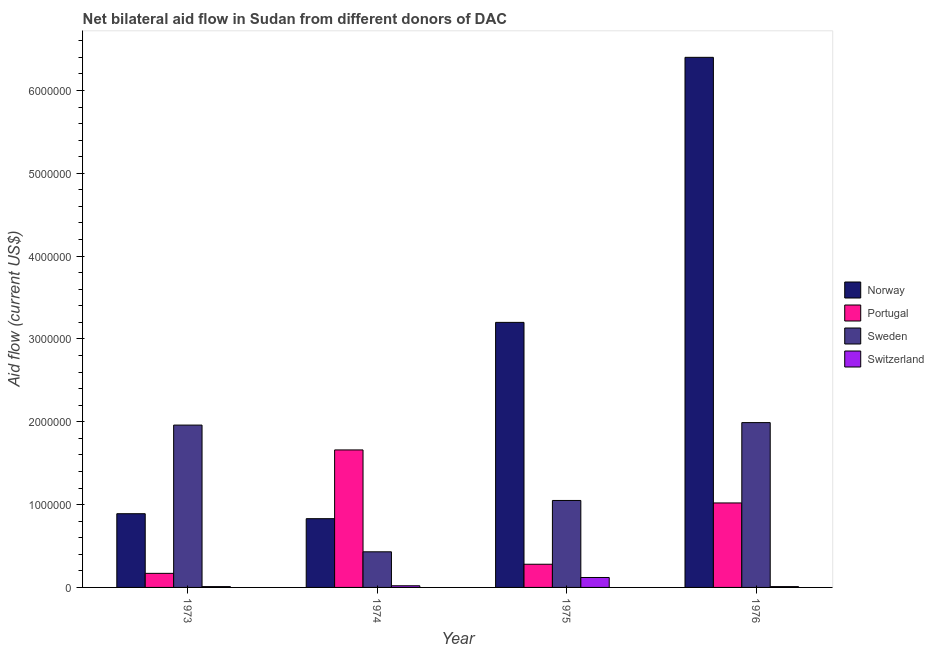How many different coloured bars are there?
Give a very brief answer. 4. How many groups of bars are there?
Offer a very short reply. 4. Are the number of bars per tick equal to the number of legend labels?
Offer a terse response. Yes. Are the number of bars on each tick of the X-axis equal?
Give a very brief answer. Yes. What is the label of the 4th group of bars from the left?
Ensure brevity in your answer.  1976. What is the amount of aid given by switzerland in 1973?
Give a very brief answer. 10000. Across all years, what is the maximum amount of aid given by portugal?
Offer a terse response. 1.66e+06. Across all years, what is the minimum amount of aid given by portugal?
Offer a very short reply. 1.70e+05. In which year was the amount of aid given by sweden maximum?
Provide a short and direct response. 1976. What is the total amount of aid given by switzerland in the graph?
Provide a succinct answer. 1.60e+05. What is the difference between the amount of aid given by switzerland in 1974 and that in 1976?
Offer a terse response. 10000. What is the difference between the amount of aid given by switzerland in 1976 and the amount of aid given by portugal in 1975?
Keep it short and to the point. -1.10e+05. What is the ratio of the amount of aid given by switzerland in 1974 to that in 1975?
Give a very brief answer. 0.17. Is the amount of aid given by norway in 1974 less than that in 1976?
Keep it short and to the point. Yes. What is the difference between the highest and the second highest amount of aid given by norway?
Keep it short and to the point. 3.20e+06. What is the difference between the highest and the lowest amount of aid given by norway?
Provide a succinct answer. 5.57e+06. In how many years, is the amount of aid given by sweden greater than the average amount of aid given by sweden taken over all years?
Offer a very short reply. 2. Is the sum of the amount of aid given by switzerland in 1973 and 1974 greater than the maximum amount of aid given by sweden across all years?
Your response must be concise. No. What does the 1st bar from the left in 1976 represents?
Ensure brevity in your answer.  Norway. What does the 2nd bar from the right in 1976 represents?
Ensure brevity in your answer.  Sweden. Is it the case that in every year, the sum of the amount of aid given by norway and amount of aid given by portugal is greater than the amount of aid given by sweden?
Keep it short and to the point. No. How many years are there in the graph?
Your answer should be compact. 4. Are the values on the major ticks of Y-axis written in scientific E-notation?
Give a very brief answer. No. Does the graph contain grids?
Ensure brevity in your answer.  No. How many legend labels are there?
Your response must be concise. 4. What is the title of the graph?
Your answer should be compact. Net bilateral aid flow in Sudan from different donors of DAC. What is the label or title of the X-axis?
Make the answer very short. Year. What is the label or title of the Y-axis?
Ensure brevity in your answer.  Aid flow (current US$). What is the Aid flow (current US$) of Norway in 1973?
Provide a short and direct response. 8.90e+05. What is the Aid flow (current US$) in Sweden in 1973?
Offer a terse response. 1.96e+06. What is the Aid flow (current US$) in Norway in 1974?
Offer a terse response. 8.30e+05. What is the Aid flow (current US$) in Portugal in 1974?
Make the answer very short. 1.66e+06. What is the Aid flow (current US$) in Sweden in 1974?
Your answer should be very brief. 4.30e+05. What is the Aid flow (current US$) in Norway in 1975?
Your answer should be compact. 3.20e+06. What is the Aid flow (current US$) in Sweden in 1975?
Keep it short and to the point. 1.05e+06. What is the Aid flow (current US$) of Norway in 1976?
Provide a succinct answer. 6.40e+06. What is the Aid flow (current US$) in Portugal in 1976?
Offer a very short reply. 1.02e+06. What is the Aid flow (current US$) in Sweden in 1976?
Your response must be concise. 1.99e+06. Across all years, what is the maximum Aid flow (current US$) in Norway?
Make the answer very short. 6.40e+06. Across all years, what is the maximum Aid flow (current US$) of Portugal?
Keep it short and to the point. 1.66e+06. Across all years, what is the maximum Aid flow (current US$) in Sweden?
Your answer should be very brief. 1.99e+06. Across all years, what is the minimum Aid flow (current US$) in Norway?
Offer a terse response. 8.30e+05. Across all years, what is the minimum Aid flow (current US$) of Portugal?
Give a very brief answer. 1.70e+05. What is the total Aid flow (current US$) in Norway in the graph?
Ensure brevity in your answer.  1.13e+07. What is the total Aid flow (current US$) in Portugal in the graph?
Your answer should be very brief. 3.13e+06. What is the total Aid flow (current US$) of Sweden in the graph?
Make the answer very short. 5.43e+06. What is the difference between the Aid flow (current US$) in Portugal in 1973 and that in 1974?
Offer a terse response. -1.49e+06. What is the difference between the Aid flow (current US$) in Sweden in 1973 and that in 1974?
Make the answer very short. 1.53e+06. What is the difference between the Aid flow (current US$) of Switzerland in 1973 and that in 1974?
Your answer should be very brief. -10000. What is the difference between the Aid flow (current US$) of Norway in 1973 and that in 1975?
Your answer should be compact. -2.31e+06. What is the difference between the Aid flow (current US$) of Portugal in 1973 and that in 1975?
Keep it short and to the point. -1.10e+05. What is the difference between the Aid flow (current US$) of Sweden in 1973 and that in 1975?
Ensure brevity in your answer.  9.10e+05. What is the difference between the Aid flow (current US$) in Norway in 1973 and that in 1976?
Your response must be concise. -5.51e+06. What is the difference between the Aid flow (current US$) in Portugal in 1973 and that in 1976?
Give a very brief answer. -8.50e+05. What is the difference between the Aid flow (current US$) in Sweden in 1973 and that in 1976?
Your answer should be very brief. -3.00e+04. What is the difference between the Aid flow (current US$) in Switzerland in 1973 and that in 1976?
Your answer should be very brief. 0. What is the difference between the Aid flow (current US$) in Norway in 1974 and that in 1975?
Provide a succinct answer. -2.37e+06. What is the difference between the Aid flow (current US$) in Portugal in 1974 and that in 1975?
Offer a terse response. 1.38e+06. What is the difference between the Aid flow (current US$) in Sweden in 1974 and that in 1975?
Ensure brevity in your answer.  -6.20e+05. What is the difference between the Aid flow (current US$) in Norway in 1974 and that in 1976?
Give a very brief answer. -5.57e+06. What is the difference between the Aid flow (current US$) in Portugal in 1974 and that in 1976?
Provide a short and direct response. 6.40e+05. What is the difference between the Aid flow (current US$) of Sweden in 1974 and that in 1976?
Offer a terse response. -1.56e+06. What is the difference between the Aid flow (current US$) of Norway in 1975 and that in 1976?
Keep it short and to the point. -3.20e+06. What is the difference between the Aid flow (current US$) of Portugal in 1975 and that in 1976?
Offer a terse response. -7.40e+05. What is the difference between the Aid flow (current US$) in Sweden in 1975 and that in 1976?
Keep it short and to the point. -9.40e+05. What is the difference between the Aid flow (current US$) of Switzerland in 1975 and that in 1976?
Ensure brevity in your answer.  1.10e+05. What is the difference between the Aid flow (current US$) of Norway in 1973 and the Aid flow (current US$) of Portugal in 1974?
Your answer should be compact. -7.70e+05. What is the difference between the Aid flow (current US$) in Norway in 1973 and the Aid flow (current US$) in Sweden in 1974?
Give a very brief answer. 4.60e+05. What is the difference between the Aid flow (current US$) of Norway in 1973 and the Aid flow (current US$) of Switzerland in 1974?
Your answer should be very brief. 8.70e+05. What is the difference between the Aid flow (current US$) of Portugal in 1973 and the Aid flow (current US$) of Sweden in 1974?
Your response must be concise. -2.60e+05. What is the difference between the Aid flow (current US$) of Portugal in 1973 and the Aid flow (current US$) of Switzerland in 1974?
Provide a short and direct response. 1.50e+05. What is the difference between the Aid flow (current US$) of Sweden in 1973 and the Aid flow (current US$) of Switzerland in 1974?
Keep it short and to the point. 1.94e+06. What is the difference between the Aid flow (current US$) of Norway in 1973 and the Aid flow (current US$) of Sweden in 1975?
Offer a very short reply. -1.60e+05. What is the difference between the Aid flow (current US$) in Norway in 1973 and the Aid flow (current US$) in Switzerland in 1975?
Your answer should be very brief. 7.70e+05. What is the difference between the Aid flow (current US$) in Portugal in 1973 and the Aid flow (current US$) in Sweden in 1975?
Offer a very short reply. -8.80e+05. What is the difference between the Aid flow (current US$) in Portugal in 1973 and the Aid flow (current US$) in Switzerland in 1975?
Keep it short and to the point. 5.00e+04. What is the difference between the Aid flow (current US$) in Sweden in 1973 and the Aid flow (current US$) in Switzerland in 1975?
Your response must be concise. 1.84e+06. What is the difference between the Aid flow (current US$) of Norway in 1973 and the Aid flow (current US$) of Sweden in 1976?
Your answer should be very brief. -1.10e+06. What is the difference between the Aid flow (current US$) in Norway in 1973 and the Aid flow (current US$) in Switzerland in 1976?
Offer a very short reply. 8.80e+05. What is the difference between the Aid flow (current US$) of Portugal in 1973 and the Aid flow (current US$) of Sweden in 1976?
Ensure brevity in your answer.  -1.82e+06. What is the difference between the Aid flow (current US$) of Sweden in 1973 and the Aid flow (current US$) of Switzerland in 1976?
Offer a very short reply. 1.95e+06. What is the difference between the Aid flow (current US$) in Norway in 1974 and the Aid flow (current US$) in Portugal in 1975?
Ensure brevity in your answer.  5.50e+05. What is the difference between the Aid flow (current US$) in Norway in 1974 and the Aid flow (current US$) in Switzerland in 1975?
Ensure brevity in your answer.  7.10e+05. What is the difference between the Aid flow (current US$) of Portugal in 1974 and the Aid flow (current US$) of Switzerland in 1975?
Your answer should be very brief. 1.54e+06. What is the difference between the Aid flow (current US$) in Sweden in 1974 and the Aid flow (current US$) in Switzerland in 1975?
Give a very brief answer. 3.10e+05. What is the difference between the Aid flow (current US$) in Norway in 1974 and the Aid flow (current US$) in Sweden in 1976?
Give a very brief answer. -1.16e+06. What is the difference between the Aid flow (current US$) in Norway in 1974 and the Aid flow (current US$) in Switzerland in 1976?
Offer a very short reply. 8.20e+05. What is the difference between the Aid flow (current US$) in Portugal in 1974 and the Aid flow (current US$) in Sweden in 1976?
Your answer should be very brief. -3.30e+05. What is the difference between the Aid flow (current US$) of Portugal in 1974 and the Aid flow (current US$) of Switzerland in 1976?
Make the answer very short. 1.65e+06. What is the difference between the Aid flow (current US$) in Norway in 1975 and the Aid flow (current US$) in Portugal in 1976?
Your answer should be very brief. 2.18e+06. What is the difference between the Aid flow (current US$) of Norway in 1975 and the Aid flow (current US$) of Sweden in 1976?
Offer a very short reply. 1.21e+06. What is the difference between the Aid flow (current US$) of Norway in 1975 and the Aid flow (current US$) of Switzerland in 1976?
Keep it short and to the point. 3.19e+06. What is the difference between the Aid flow (current US$) of Portugal in 1975 and the Aid flow (current US$) of Sweden in 1976?
Your answer should be very brief. -1.71e+06. What is the difference between the Aid flow (current US$) in Portugal in 1975 and the Aid flow (current US$) in Switzerland in 1976?
Your answer should be very brief. 2.70e+05. What is the difference between the Aid flow (current US$) of Sweden in 1975 and the Aid flow (current US$) of Switzerland in 1976?
Your response must be concise. 1.04e+06. What is the average Aid flow (current US$) in Norway per year?
Provide a succinct answer. 2.83e+06. What is the average Aid flow (current US$) of Portugal per year?
Keep it short and to the point. 7.82e+05. What is the average Aid flow (current US$) in Sweden per year?
Ensure brevity in your answer.  1.36e+06. What is the average Aid flow (current US$) in Switzerland per year?
Give a very brief answer. 4.00e+04. In the year 1973, what is the difference between the Aid flow (current US$) in Norway and Aid flow (current US$) in Portugal?
Your answer should be very brief. 7.20e+05. In the year 1973, what is the difference between the Aid flow (current US$) of Norway and Aid flow (current US$) of Sweden?
Your answer should be compact. -1.07e+06. In the year 1973, what is the difference between the Aid flow (current US$) in Norway and Aid flow (current US$) in Switzerland?
Make the answer very short. 8.80e+05. In the year 1973, what is the difference between the Aid flow (current US$) of Portugal and Aid flow (current US$) of Sweden?
Your answer should be very brief. -1.79e+06. In the year 1973, what is the difference between the Aid flow (current US$) of Sweden and Aid flow (current US$) of Switzerland?
Ensure brevity in your answer.  1.95e+06. In the year 1974, what is the difference between the Aid flow (current US$) of Norway and Aid flow (current US$) of Portugal?
Offer a very short reply. -8.30e+05. In the year 1974, what is the difference between the Aid flow (current US$) in Norway and Aid flow (current US$) in Switzerland?
Provide a succinct answer. 8.10e+05. In the year 1974, what is the difference between the Aid flow (current US$) in Portugal and Aid flow (current US$) in Sweden?
Provide a succinct answer. 1.23e+06. In the year 1974, what is the difference between the Aid flow (current US$) of Portugal and Aid flow (current US$) of Switzerland?
Keep it short and to the point. 1.64e+06. In the year 1974, what is the difference between the Aid flow (current US$) in Sweden and Aid flow (current US$) in Switzerland?
Offer a terse response. 4.10e+05. In the year 1975, what is the difference between the Aid flow (current US$) in Norway and Aid flow (current US$) in Portugal?
Provide a succinct answer. 2.92e+06. In the year 1975, what is the difference between the Aid flow (current US$) in Norway and Aid flow (current US$) in Sweden?
Ensure brevity in your answer.  2.15e+06. In the year 1975, what is the difference between the Aid flow (current US$) in Norway and Aid flow (current US$) in Switzerland?
Keep it short and to the point. 3.08e+06. In the year 1975, what is the difference between the Aid flow (current US$) of Portugal and Aid flow (current US$) of Sweden?
Your answer should be very brief. -7.70e+05. In the year 1975, what is the difference between the Aid flow (current US$) in Sweden and Aid flow (current US$) in Switzerland?
Your answer should be compact. 9.30e+05. In the year 1976, what is the difference between the Aid flow (current US$) of Norway and Aid flow (current US$) of Portugal?
Provide a short and direct response. 5.38e+06. In the year 1976, what is the difference between the Aid flow (current US$) in Norway and Aid flow (current US$) in Sweden?
Keep it short and to the point. 4.41e+06. In the year 1976, what is the difference between the Aid flow (current US$) of Norway and Aid flow (current US$) of Switzerland?
Provide a short and direct response. 6.39e+06. In the year 1976, what is the difference between the Aid flow (current US$) in Portugal and Aid flow (current US$) in Sweden?
Offer a very short reply. -9.70e+05. In the year 1976, what is the difference between the Aid flow (current US$) in Portugal and Aid flow (current US$) in Switzerland?
Your response must be concise. 1.01e+06. In the year 1976, what is the difference between the Aid flow (current US$) in Sweden and Aid flow (current US$) in Switzerland?
Ensure brevity in your answer.  1.98e+06. What is the ratio of the Aid flow (current US$) in Norway in 1973 to that in 1974?
Give a very brief answer. 1.07. What is the ratio of the Aid flow (current US$) of Portugal in 1973 to that in 1974?
Offer a very short reply. 0.1. What is the ratio of the Aid flow (current US$) in Sweden in 1973 to that in 1974?
Provide a short and direct response. 4.56. What is the ratio of the Aid flow (current US$) in Switzerland in 1973 to that in 1974?
Offer a very short reply. 0.5. What is the ratio of the Aid flow (current US$) of Norway in 1973 to that in 1975?
Your response must be concise. 0.28. What is the ratio of the Aid flow (current US$) in Portugal in 1973 to that in 1975?
Make the answer very short. 0.61. What is the ratio of the Aid flow (current US$) of Sweden in 1973 to that in 1975?
Your answer should be compact. 1.87. What is the ratio of the Aid flow (current US$) in Switzerland in 1973 to that in 1975?
Your answer should be very brief. 0.08. What is the ratio of the Aid flow (current US$) of Norway in 1973 to that in 1976?
Give a very brief answer. 0.14. What is the ratio of the Aid flow (current US$) in Portugal in 1973 to that in 1976?
Ensure brevity in your answer.  0.17. What is the ratio of the Aid flow (current US$) in Sweden in 1973 to that in 1976?
Ensure brevity in your answer.  0.98. What is the ratio of the Aid flow (current US$) of Switzerland in 1973 to that in 1976?
Your answer should be compact. 1. What is the ratio of the Aid flow (current US$) of Norway in 1974 to that in 1975?
Provide a succinct answer. 0.26. What is the ratio of the Aid flow (current US$) in Portugal in 1974 to that in 1975?
Ensure brevity in your answer.  5.93. What is the ratio of the Aid flow (current US$) in Sweden in 1974 to that in 1975?
Your answer should be compact. 0.41. What is the ratio of the Aid flow (current US$) of Switzerland in 1974 to that in 1975?
Your answer should be compact. 0.17. What is the ratio of the Aid flow (current US$) in Norway in 1974 to that in 1976?
Provide a short and direct response. 0.13. What is the ratio of the Aid flow (current US$) of Portugal in 1974 to that in 1976?
Provide a short and direct response. 1.63. What is the ratio of the Aid flow (current US$) of Sweden in 1974 to that in 1976?
Keep it short and to the point. 0.22. What is the ratio of the Aid flow (current US$) in Norway in 1975 to that in 1976?
Provide a short and direct response. 0.5. What is the ratio of the Aid flow (current US$) in Portugal in 1975 to that in 1976?
Offer a very short reply. 0.27. What is the ratio of the Aid flow (current US$) of Sweden in 1975 to that in 1976?
Give a very brief answer. 0.53. What is the difference between the highest and the second highest Aid flow (current US$) in Norway?
Keep it short and to the point. 3.20e+06. What is the difference between the highest and the second highest Aid flow (current US$) of Portugal?
Ensure brevity in your answer.  6.40e+05. What is the difference between the highest and the second highest Aid flow (current US$) of Switzerland?
Keep it short and to the point. 1.00e+05. What is the difference between the highest and the lowest Aid flow (current US$) in Norway?
Give a very brief answer. 5.57e+06. What is the difference between the highest and the lowest Aid flow (current US$) of Portugal?
Keep it short and to the point. 1.49e+06. What is the difference between the highest and the lowest Aid flow (current US$) in Sweden?
Your answer should be compact. 1.56e+06. 